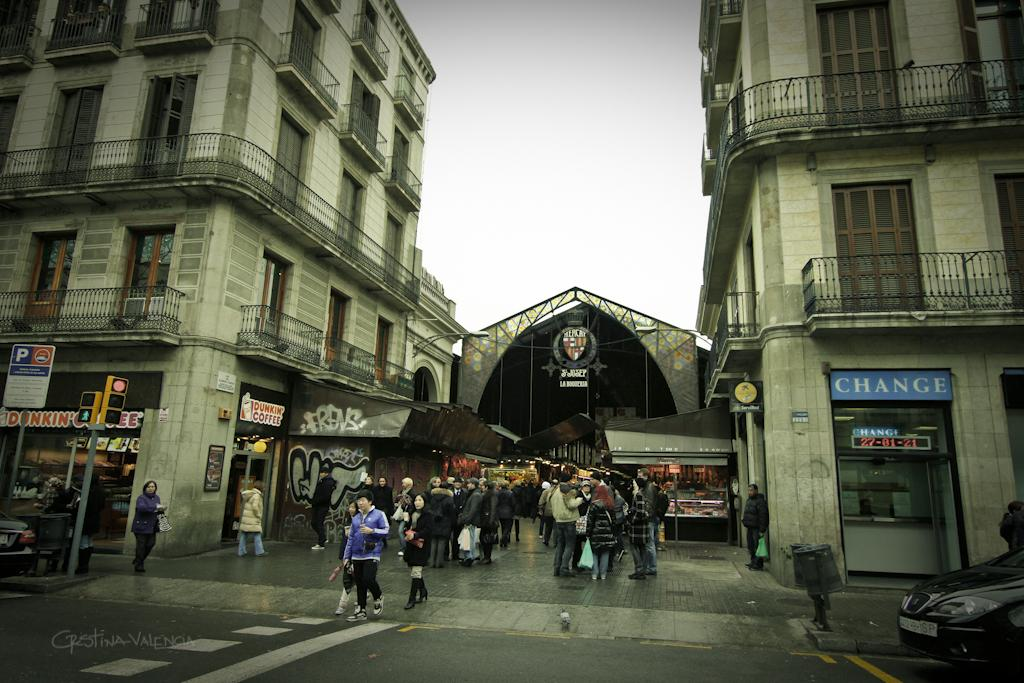Who or what can be seen in the image? There are people in the image. What objects are present in the image that are related to waste management? There are dustbins in the image. What type of transportation can be seen in the image? There are vehicles in the image. What structures are present in the image that support electrical wires or other utilities? There are poles in the image. What objects are present in the image that regulate traffic flow? There are traffic signals in the image. What objects are present in the image that display information or advertisements? There are boards in the image. What type of man-made structures can be seen in the image? There are buildings in the image. What part of the natural environment is visible in the background of the image? The sky is visible in the background of the image. Can you tell me how many buttons are on the cave in the image? There is no cave present in the image, and therefore no buttons can be found on it. What type of sign is visible on the button in the image? There is no button or sign present in the image. 